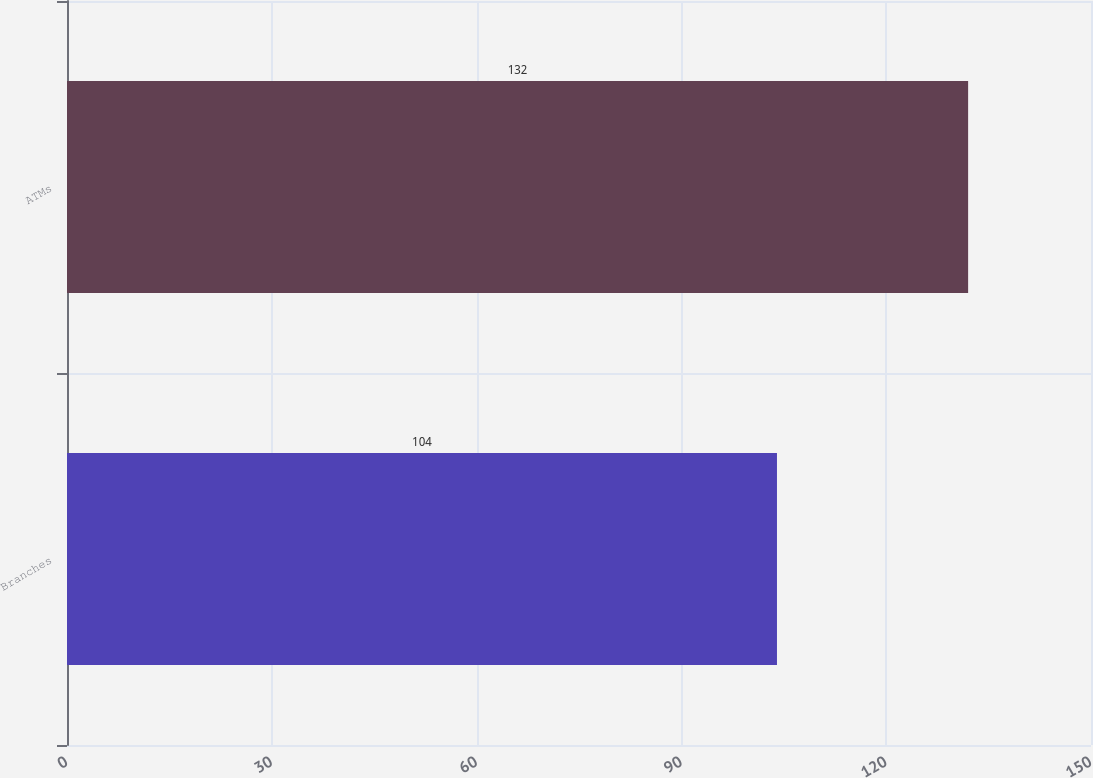Convert chart to OTSL. <chart><loc_0><loc_0><loc_500><loc_500><bar_chart><fcel>Branches<fcel>ATMs<nl><fcel>104<fcel>132<nl></chart> 